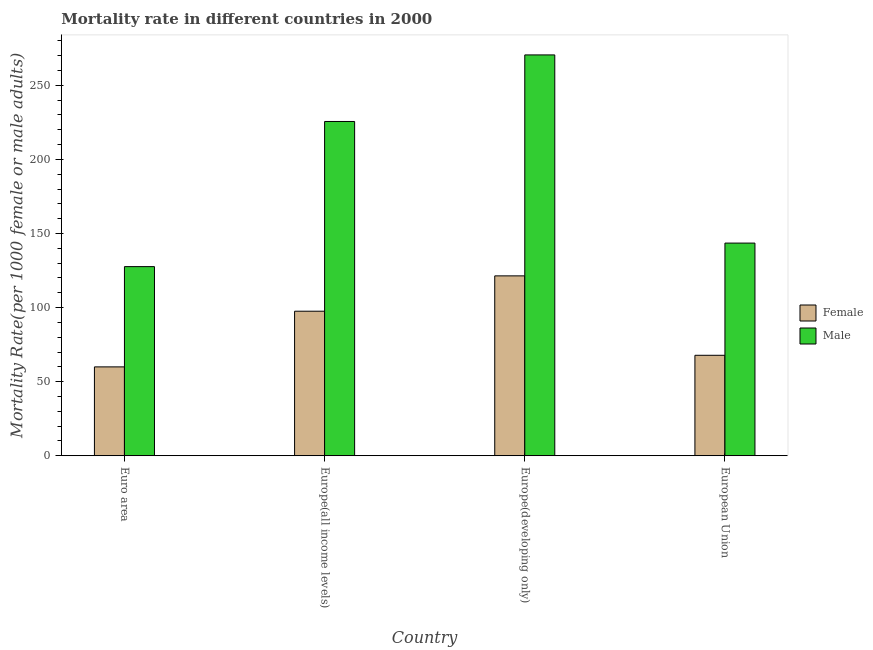How many bars are there on the 3rd tick from the right?
Make the answer very short. 2. What is the label of the 2nd group of bars from the left?
Your response must be concise. Europe(all income levels). In how many cases, is the number of bars for a given country not equal to the number of legend labels?
Your answer should be very brief. 0. What is the female mortality rate in Europe(developing only)?
Make the answer very short. 121.39. Across all countries, what is the maximum male mortality rate?
Provide a succinct answer. 270.52. Across all countries, what is the minimum female mortality rate?
Your answer should be compact. 59.97. In which country was the male mortality rate maximum?
Keep it short and to the point. Europe(developing only). What is the total male mortality rate in the graph?
Your answer should be compact. 767.27. What is the difference between the female mortality rate in Europe(all income levels) and that in Europe(developing only)?
Your answer should be very brief. -23.85. What is the difference between the male mortality rate in European Union and the female mortality rate in Europe(developing only)?
Keep it short and to the point. 22.13. What is the average male mortality rate per country?
Your answer should be very brief. 191.82. What is the difference between the male mortality rate and female mortality rate in European Union?
Provide a short and direct response. 75.73. In how many countries, is the male mortality rate greater than 10 ?
Offer a terse response. 4. What is the ratio of the female mortality rate in Euro area to that in European Union?
Offer a very short reply. 0.88. Is the female mortality rate in Europe(developing only) less than that in European Union?
Offer a terse response. No. What is the difference between the highest and the second highest male mortality rate?
Your answer should be very brief. 44.92. What is the difference between the highest and the lowest male mortality rate?
Offer a very short reply. 142.88. What does the 2nd bar from the right in Euro area represents?
Provide a short and direct response. Female. How many bars are there?
Offer a very short reply. 8. Are all the bars in the graph horizontal?
Your answer should be compact. No. Are the values on the major ticks of Y-axis written in scientific E-notation?
Your answer should be compact. No. How are the legend labels stacked?
Ensure brevity in your answer.  Vertical. What is the title of the graph?
Offer a very short reply. Mortality rate in different countries in 2000. What is the label or title of the X-axis?
Make the answer very short. Country. What is the label or title of the Y-axis?
Provide a succinct answer. Mortality Rate(per 1000 female or male adults). What is the Mortality Rate(per 1000 female or male adults) in Female in Euro area?
Make the answer very short. 59.97. What is the Mortality Rate(per 1000 female or male adults) of Male in Euro area?
Give a very brief answer. 127.64. What is the Mortality Rate(per 1000 female or male adults) in Female in Europe(all income levels)?
Your answer should be very brief. 97.54. What is the Mortality Rate(per 1000 female or male adults) in Male in Europe(all income levels)?
Ensure brevity in your answer.  225.59. What is the Mortality Rate(per 1000 female or male adults) in Female in Europe(developing only)?
Offer a terse response. 121.39. What is the Mortality Rate(per 1000 female or male adults) in Male in Europe(developing only)?
Offer a terse response. 270.52. What is the Mortality Rate(per 1000 female or male adults) of Female in European Union?
Your answer should be compact. 67.79. What is the Mortality Rate(per 1000 female or male adults) in Male in European Union?
Provide a succinct answer. 143.52. Across all countries, what is the maximum Mortality Rate(per 1000 female or male adults) in Female?
Make the answer very short. 121.39. Across all countries, what is the maximum Mortality Rate(per 1000 female or male adults) in Male?
Provide a succinct answer. 270.52. Across all countries, what is the minimum Mortality Rate(per 1000 female or male adults) of Female?
Provide a succinct answer. 59.97. Across all countries, what is the minimum Mortality Rate(per 1000 female or male adults) of Male?
Offer a terse response. 127.64. What is the total Mortality Rate(per 1000 female or male adults) of Female in the graph?
Offer a very short reply. 346.69. What is the total Mortality Rate(per 1000 female or male adults) of Male in the graph?
Your response must be concise. 767.27. What is the difference between the Mortality Rate(per 1000 female or male adults) in Female in Euro area and that in Europe(all income levels)?
Your answer should be very brief. -37.57. What is the difference between the Mortality Rate(per 1000 female or male adults) of Male in Euro area and that in Europe(all income levels)?
Keep it short and to the point. -97.96. What is the difference between the Mortality Rate(per 1000 female or male adults) of Female in Euro area and that in Europe(developing only)?
Ensure brevity in your answer.  -61.42. What is the difference between the Mortality Rate(per 1000 female or male adults) of Male in Euro area and that in Europe(developing only)?
Provide a succinct answer. -142.88. What is the difference between the Mortality Rate(per 1000 female or male adults) of Female in Euro area and that in European Union?
Provide a succinct answer. -7.82. What is the difference between the Mortality Rate(per 1000 female or male adults) in Male in Euro area and that in European Union?
Offer a terse response. -15.88. What is the difference between the Mortality Rate(per 1000 female or male adults) of Female in Europe(all income levels) and that in Europe(developing only)?
Keep it short and to the point. -23.85. What is the difference between the Mortality Rate(per 1000 female or male adults) in Male in Europe(all income levels) and that in Europe(developing only)?
Your answer should be very brief. -44.92. What is the difference between the Mortality Rate(per 1000 female or male adults) of Female in Europe(all income levels) and that in European Union?
Your answer should be compact. 29.74. What is the difference between the Mortality Rate(per 1000 female or male adults) in Male in Europe(all income levels) and that in European Union?
Keep it short and to the point. 82.08. What is the difference between the Mortality Rate(per 1000 female or male adults) in Female in Europe(developing only) and that in European Union?
Provide a short and direct response. 53.6. What is the difference between the Mortality Rate(per 1000 female or male adults) in Male in Europe(developing only) and that in European Union?
Provide a short and direct response. 127. What is the difference between the Mortality Rate(per 1000 female or male adults) in Female in Euro area and the Mortality Rate(per 1000 female or male adults) in Male in Europe(all income levels)?
Offer a very short reply. -165.63. What is the difference between the Mortality Rate(per 1000 female or male adults) of Female in Euro area and the Mortality Rate(per 1000 female or male adults) of Male in Europe(developing only)?
Your answer should be very brief. -210.55. What is the difference between the Mortality Rate(per 1000 female or male adults) in Female in Euro area and the Mortality Rate(per 1000 female or male adults) in Male in European Union?
Your answer should be compact. -83.55. What is the difference between the Mortality Rate(per 1000 female or male adults) of Female in Europe(all income levels) and the Mortality Rate(per 1000 female or male adults) of Male in Europe(developing only)?
Your answer should be very brief. -172.98. What is the difference between the Mortality Rate(per 1000 female or male adults) in Female in Europe(all income levels) and the Mortality Rate(per 1000 female or male adults) in Male in European Union?
Make the answer very short. -45.98. What is the difference between the Mortality Rate(per 1000 female or male adults) in Female in Europe(developing only) and the Mortality Rate(per 1000 female or male adults) in Male in European Union?
Provide a succinct answer. -22.13. What is the average Mortality Rate(per 1000 female or male adults) in Female per country?
Ensure brevity in your answer.  86.67. What is the average Mortality Rate(per 1000 female or male adults) of Male per country?
Ensure brevity in your answer.  191.82. What is the difference between the Mortality Rate(per 1000 female or male adults) of Female and Mortality Rate(per 1000 female or male adults) of Male in Euro area?
Provide a short and direct response. -67.67. What is the difference between the Mortality Rate(per 1000 female or male adults) of Female and Mortality Rate(per 1000 female or male adults) of Male in Europe(all income levels)?
Your answer should be compact. -128.06. What is the difference between the Mortality Rate(per 1000 female or male adults) of Female and Mortality Rate(per 1000 female or male adults) of Male in Europe(developing only)?
Offer a terse response. -149.13. What is the difference between the Mortality Rate(per 1000 female or male adults) in Female and Mortality Rate(per 1000 female or male adults) in Male in European Union?
Ensure brevity in your answer.  -75.73. What is the ratio of the Mortality Rate(per 1000 female or male adults) in Female in Euro area to that in Europe(all income levels)?
Offer a terse response. 0.61. What is the ratio of the Mortality Rate(per 1000 female or male adults) of Male in Euro area to that in Europe(all income levels)?
Provide a short and direct response. 0.57. What is the ratio of the Mortality Rate(per 1000 female or male adults) of Female in Euro area to that in Europe(developing only)?
Your response must be concise. 0.49. What is the ratio of the Mortality Rate(per 1000 female or male adults) in Male in Euro area to that in Europe(developing only)?
Your answer should be compact. 0.47. What is the ratio of the Mortality Rate(per 1000 female or male adults) in Female in Euro area to that in European Union?
Keep it short and to the point. 0.88. What is the ratio of the Mortality Rate(per 1000 female or male adults) in Male in Euro area to that in European Union?
Ensure brevity in your answer.  0.89. What is the ratio of the Mortality Rate(per 1000 female or male adults) in Female in Europe(all income levels) to that in Europe(developing only)?
Give a very brief answer. 0.8. What is the ratio of the Mortality Rate(per 1000 female or male adults) of Male in Europe(all income levels) to that in Europe(developing only)?
Your answer should be very brief. 0.83. What is the ratio of the Mortality Rate(per 1000 female or male adults) in Female in Europe(all income levels) to that in European Union?
Offer a terse response. 1.44. What is the ratio of the Mortality Rate(per 1000 female or male adults) in Male in Europe(all income levels) to that in European Union?
Provide a succinct answer. 1.57. What is the ratio of the Mortality Rate(per 1000 female or male adults) in Female in Europe(developing only) to that in European Union?
Provide a short and direct response. 1.79. What is the ratio of the Mortality Rate(per 1000 female or male adults) of Male in Europe(developing only) to that in European Union?
Offer a terse response. 1.88. What is the difference between the highest and the second highest Mortality Rate(per 1000 female or male adults) of Female?
Your response must be concise. 23.85. What is the difference between the highest and the second highest Mortality Rate(per 1000 female or male adults) in Male?
Offer a terse response. 44.92. What is the difference between the highest and the lowest Mortality Rate(per 1000 female or male adults) of Female?
Keep it short and to the point. 61.42. What is the difference between the highest and the lowest Mortality Rate(per 1000 female or male adults) in Male?
Offer a terse response. 142.88. 